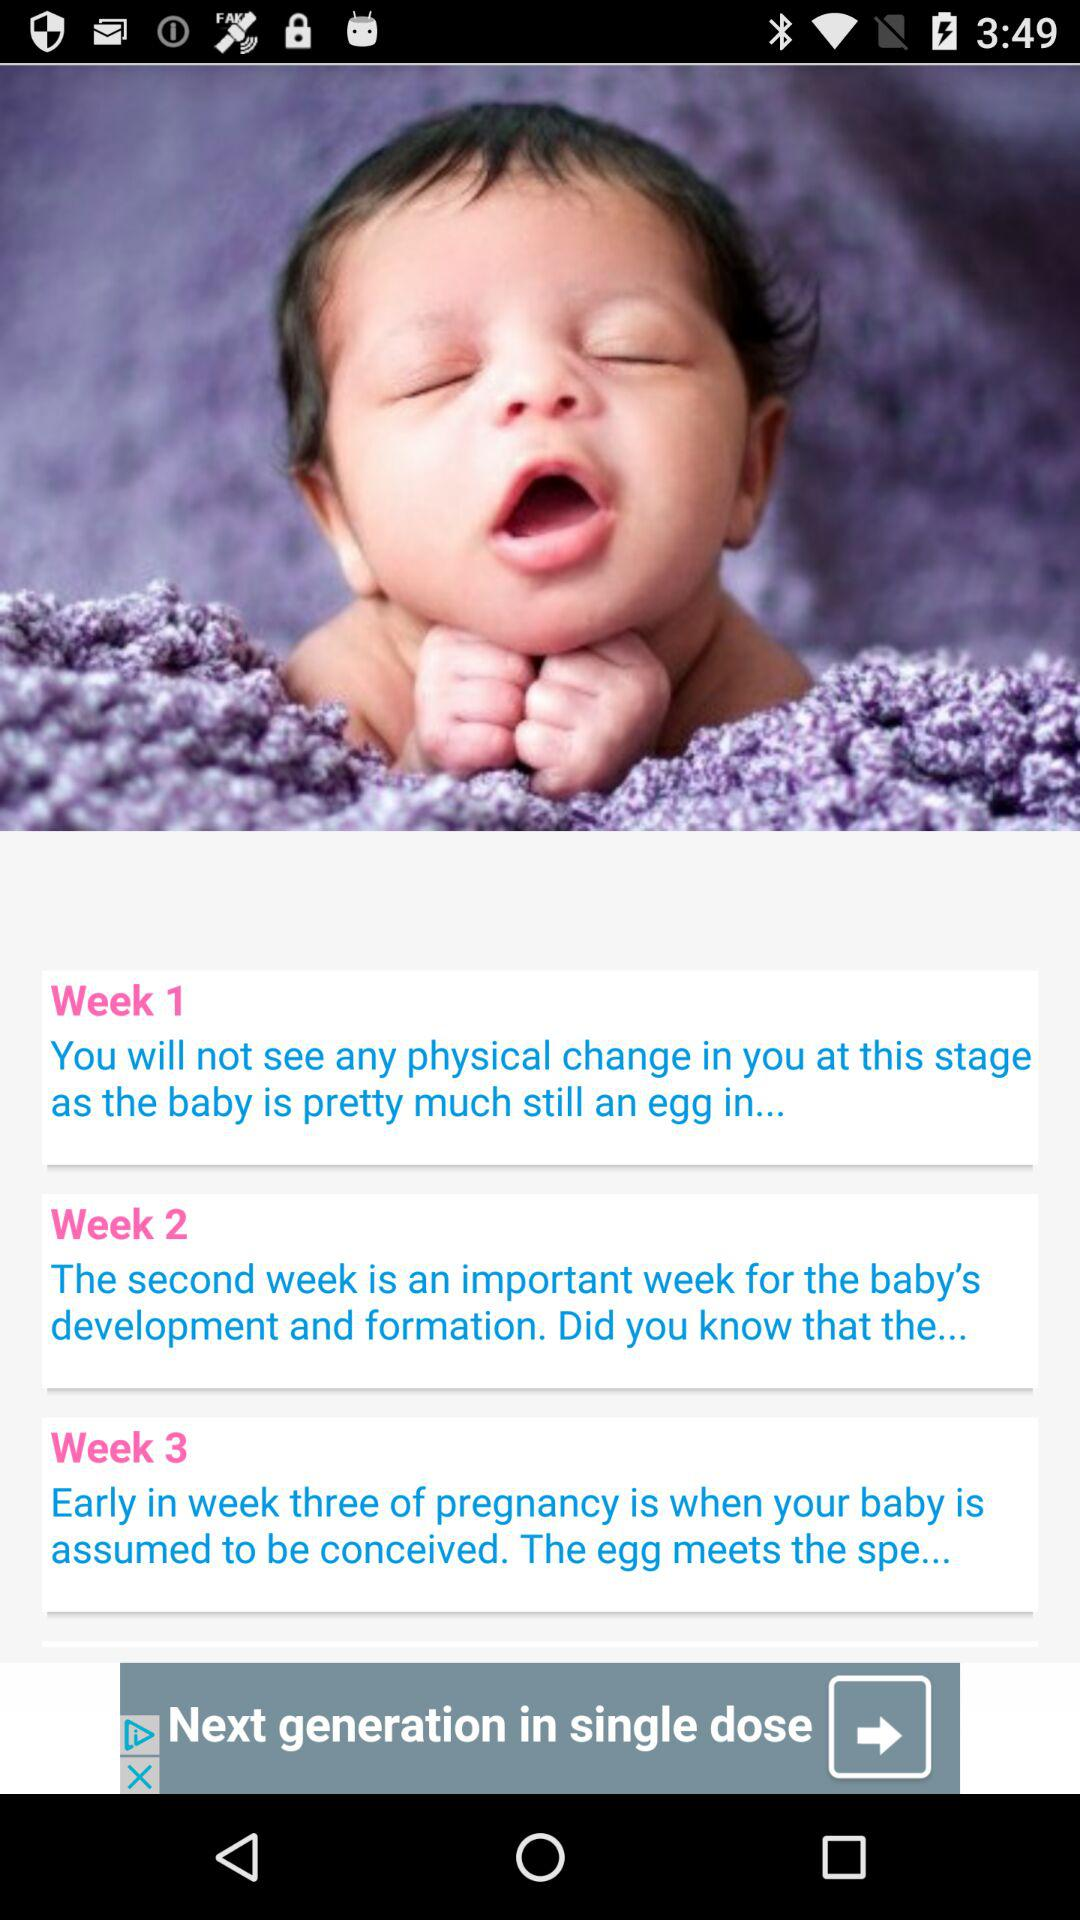What week is important for the baby's development and formation? The week that is important for the baby's development and formation is the 2nd week. 